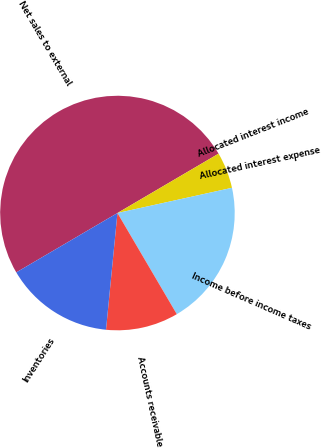Convert chart to OTSL. <chart><loc_0><loc_0><loc_500><loc_500><pie_chart><fcel>Net sales to external<fcel>Allocated interest income<fcel>Allocated interest expense<fcel>Income before income taxes<fcel>Accounts receivable<fcel>Inventories<nl><fcel>49.99%<fcel>5.0%<fcel>0.0%<fcel>20.0%<fcel>10.0%<fcel>15.0%<nl></chart> 